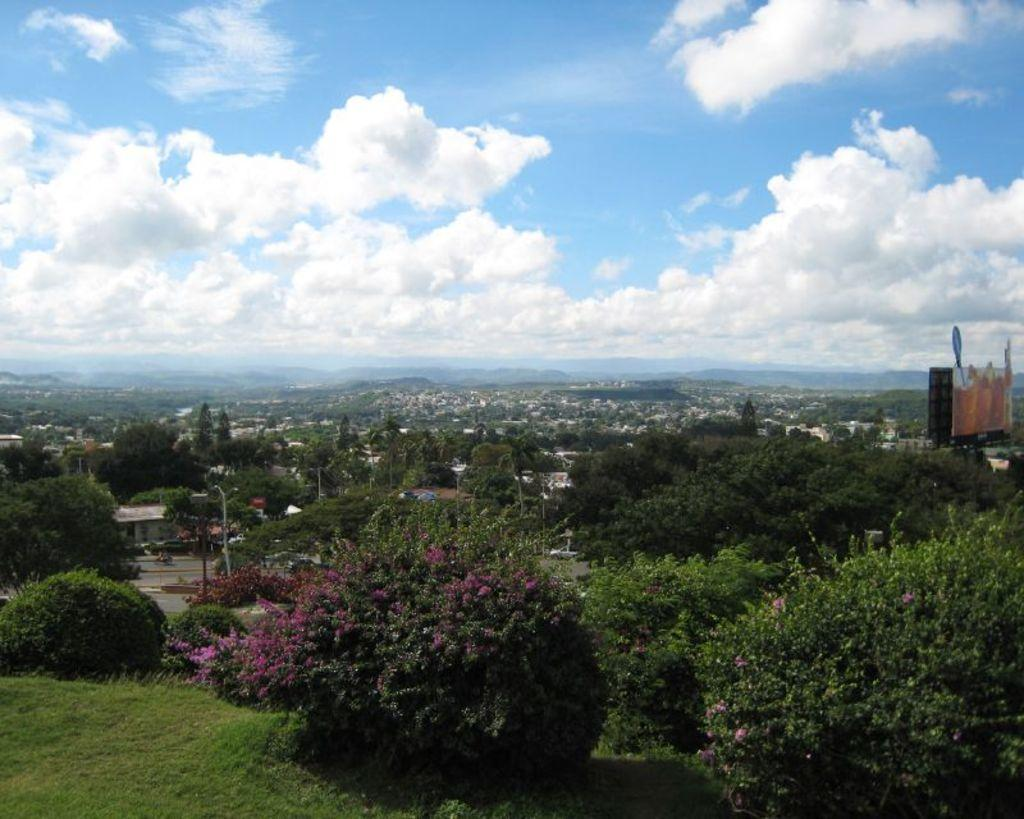What type of natural vegetation is visible in the image? There are trees in the image. What man-made structures can be seen in the image? There are poles and buildings visible in the image. What can be seen in the sky in the image? There are clouds visible in the image. Can you see any cellars in the image? There is no mention of a cellar in the image, so it cannot be determined if one is present. What type of fan is visible in the image? There is no fan present in the image. 